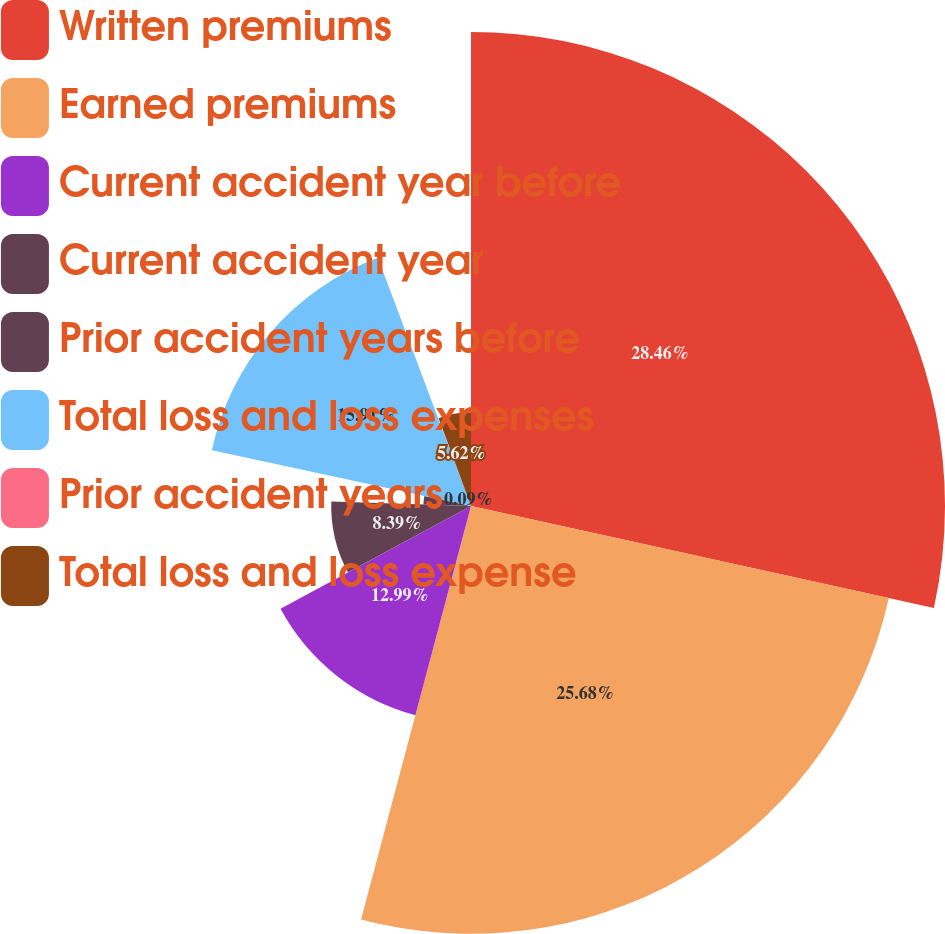<chart> <loc_0><loc_0><loc_500><loc_500><pie_chart><fcel>Written premiums<fcel>Earned premiums<fcel>Current accident year before<fcel>Current accident year<fcel>Prior accident years before<fcel>Total loss and loss expenses<fcel>Prior accident years<fcel>Total loss and loss expense<nl><fcel>28.45%<fcel>25.68%<fcel>12.99%<fcel>8.39%<fcel>2.86%<fcel>15.91%<fcel>0.09%<fcel>5.62%<nl></chart> 